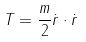Convert formula to latex. <formula><loc_0><loc_0><loc_500><loc_500>T = \frac { m } { 2 } \dot { r } \cdot \dot { r }</formula> 